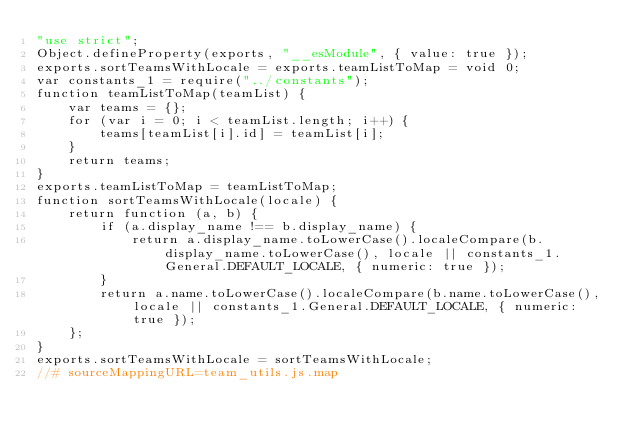Convert code to text. <code><loc_0><loc_0><loc_500><loc_500><_JavaScript_>"use strict";
Object.defineProperty(exports, "__esModule", { value: true });
exports.sortTeamsWithLocale = exports.teamListToMap = void 0;
var constants_1 = require("../constants");
function teamListToMap(teamList) {
    var teams = {};
    for (var i = 0; i < teamList.length; i++) {
        teams[teamList[i].id] = teamList[i];
    }
    return teams;
}
exports.teamListToMap = teamListToMap;
function sortTeamsWithLocale(locale) {
    return function (a, b) {
        if (a.display_name !== b.display_name) {
            return a.display_name.toLowerCase().localeCompare(b.display_name.toLowerCase(), locale || constants_1.General.DEFAULT_LOCALE, { numeric: true });
        }
        return a.name.toLowerCase().localeCompare(b.name.toLowerCase(), locale || constants_1.General.DEFAULT_LOCALE, { numeric: true });
    };
}
exports.sortTeamsWithLocale = sortTeamsWithLocale;
//# sourceMappingURL=team_utils.js.map</code> 